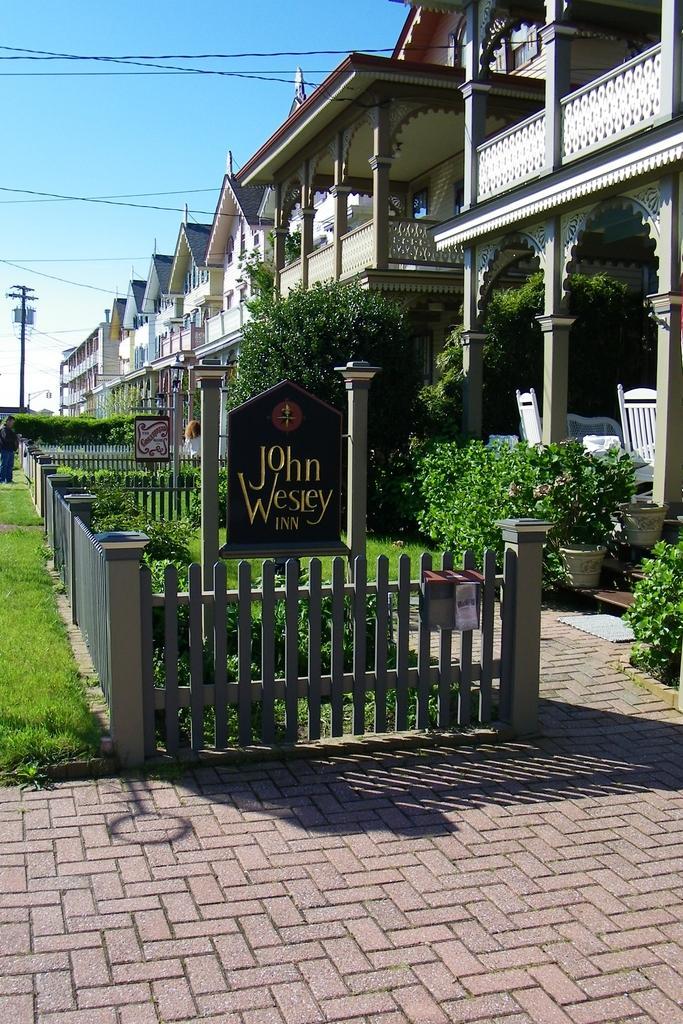Can you describe this image briefly? In this image we can see many buildings. There are many plants in the image. We can see the sky in the image. There are few cables in the image. There is a pole at the left side of the image. There is a grassy land in the image. There is a board in the image. 